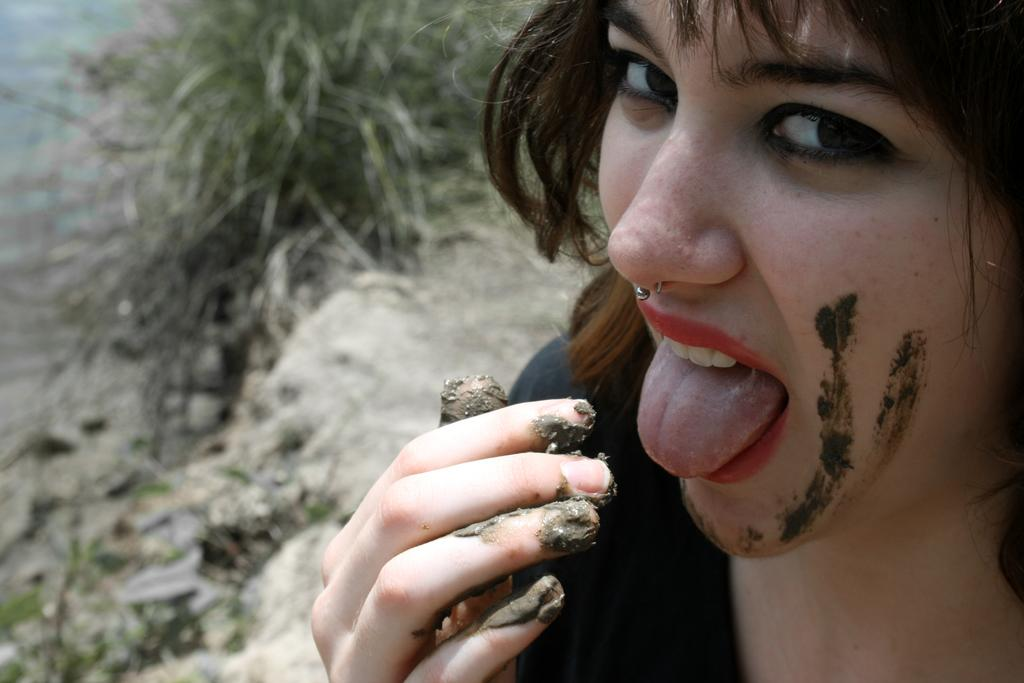Who is the main subject in the image? There is a woman in the image. Where is the woman positioned in the image? The woman is in the front of the image. What can be seen on the left side of the image? There is a plant on the left side of the image. Can you describe the background of the image? The background of the image is blurry. What type of earth can be seen in the image? There is no earth visible in the image; it features a woman in the front, a plant on the left side, and a blurry background. 